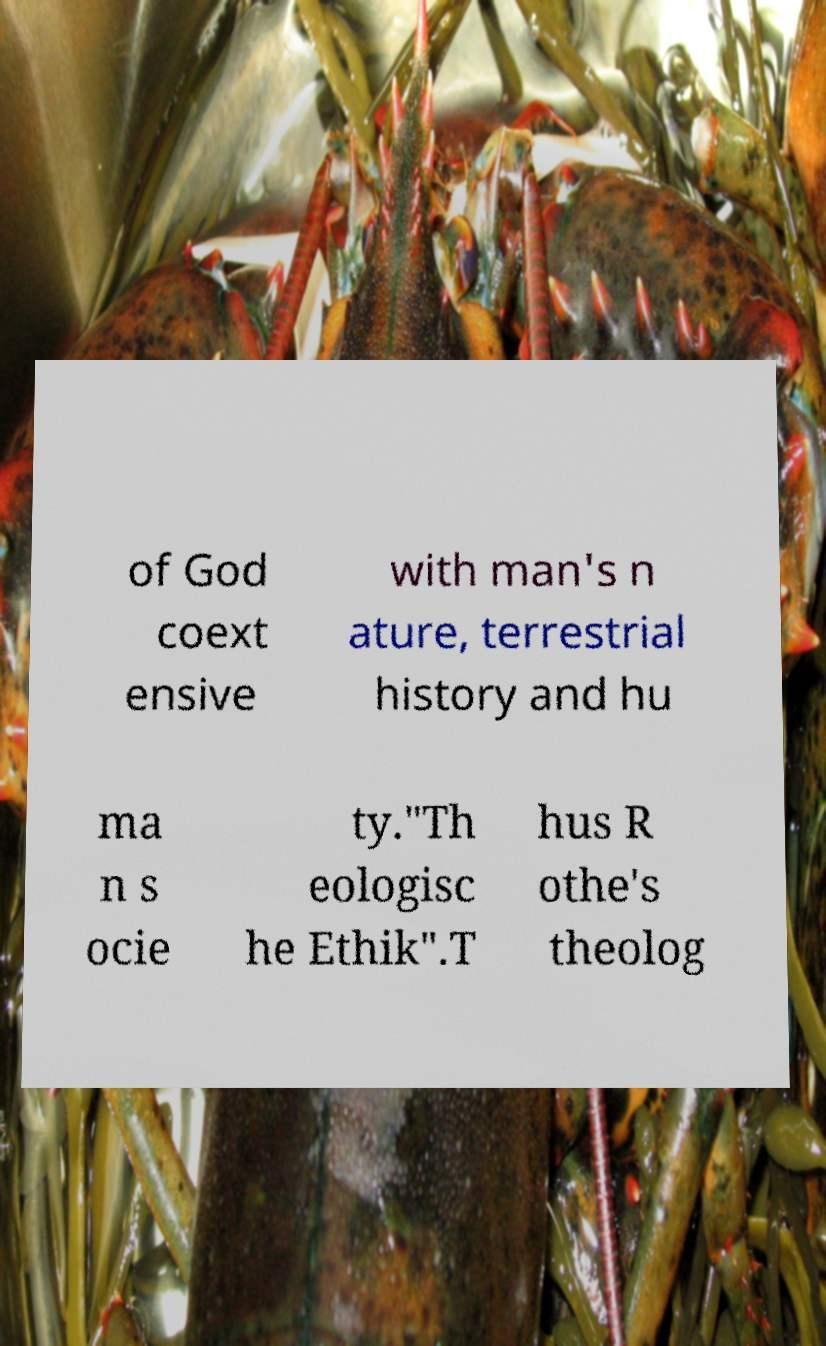Could you extract and type out the text from this image? of God coext ensive with man's n ature, terrestrial history and hu ma n s ocie ty."Th eologisc he Ethik".T hus R othe's theolog 